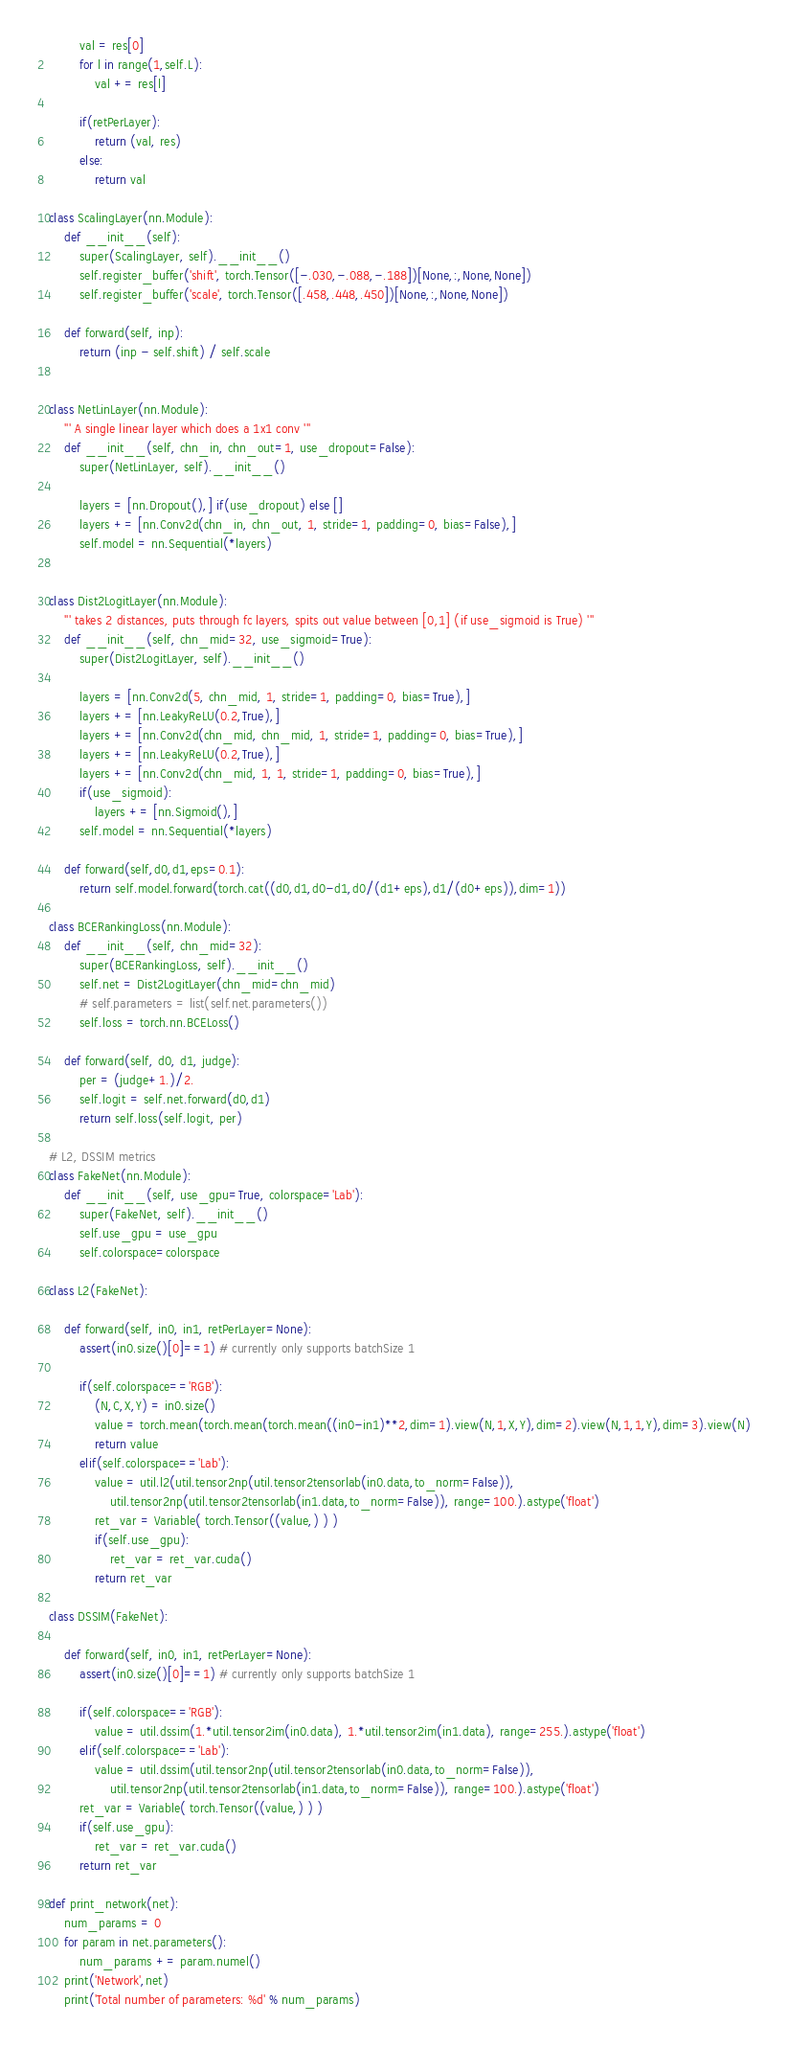<code> <loc_0><loc_0><loc_500><loc_500><_Python_>
        val = res[0]
        for l in range(1,self.L):
            val += res[l]
        
        if(retPerLayer):
            return (val, res)
        else:
            return val

class ScalingLayer(nn.Module):
    def __init__(self):
        super(ScalingLayer, self).__init__()
        self.register_buffer('shift', torch.Tensor([-.030,-.088,-.188])[None,:,None,None])
        self.register_buffer('scale', torch.Tensor([.458,.448,.450])[None,:,None,None])

    def forward(self, inp):
        return (inp - self.shift) / self.scale


class NetLinLayer(nn.Module):
    ''' A single linear layer which does a 1x1 conv '''
    def __init__(self, chn_in, chn_out=1, use_dropout=False):
        super(NetLinLayer, self).__init__()

        layers = [nn.Dropout(),] if(use_dropout) else []
        layers += [nn.Conv2d(chn_in, chn_out, 1, stride=1, padding=0, bias=False),]
        self.model = nn.Sequential(*layers)


class Dist2LogitLayer(nn.Module):
    ''' takes 2 distances, puts through fc layers, spits out value between [0,1] (if use_sigmoid is True) '''
    def __init__(self, chn_mid=32, use_sigmoid=True):
        super(Dist2LogitLayer, self).__init__()

        layers = [nn.Conv2d(5, chn_mid, 1, stride=1, padding=0, bias=True),]
        layers += [nn.LeakyReLU(0.2,True),]
        layers += [nn.Conv2d(chn_mid, chn_mid, 1, stride=1, padding=0, bias=True),]
        layers += [nn.LeakyReLU(0.2,True),]
        layers += [nn.Conv2d(chn_mid, 1, 1, stride=1, padding=0, bias=True),]
        if(use_sigmoid):
            layers += [nn.Sigmoid(),]
        self.model = nn.Sequential(*layers)

    def forward(self,d0,d1,eps=0.1):
        return self.model.forward(torch.cat((d0,d1,d0-d1,d0/(d1+eps),d1/(d0+eps)),dim=1))

class BCERankingLoss(nn.Module):
    def __init__(self, chn_mid=32):
        super(BCERankingLoss, self).__init__()
        self.net = Dist2LogitLayer(chn_mid=chn_mid)
        # self.parameters = list(self.net.parameters())
        self.loss = torch.nn.BCELoss()

    def forward(self, d0, d1, judge):
        per = (judge+1.)/2.
        self.logit = self.net.forward(d0,d1)
        return self.loss(self.logit, per)

# L2, DSSIM metrics
class FakeNet(nn.Module):
    def __init__(self, use_gpu=True, colorspace='Lab'):
        super(FakeNet, self).__init__()
        self.use_gpu = use_gpu
        self.colorspace=colorspace

class L2(FakeNet):

    def forward(self, in0, in1, retPerLayer=None):
        assert(in0.size()[0]==1) # currently only supports batchSize 1

        if(self.colorspace=='RGB'):
            (N,C,X,Y) = in0.size()
            value = torch.mean(torch.mean(torch.mean((in0-in1)**2,dim=1).view(N,1,X,Y),dim=2).view(N,1,1,Y),dim=3).view(N)
            return value
        elif(self.colorspace=='Lab'):
            value = util.l2(util.tensor2np(util.tensor2tensorlab(in0.data,to_norm=False)), 
                util.tensor2np(util.tensor2tensorlab(in1.data,to_norm=False)), range=100.).astype('float')
            ret_var = Variable( torch.Tensor((value,) ) )
            if(self.use_gpu):
                ret_var = ret_var.cuda()
            return ret_var

class DSSIM(FakeNet):

    def forward(self, in0, in1, retPerLayer=None):
        assert(in0.size()[0]==1) # currently only supports batchSize 1

        if(self.colorspace=='RGB'):
            value = util.dssim(1.*util.tensor2im(in0.data), 1.*util.tensor2im(in1.data), range=255.).astype('float')
        elif(self.colorspace=='Lab'):
            value = util.dssim(util.tensor2np(util.tensor2tensorlab(in0.data,to_norm=False)), 
                util.tensor2np(util.tensor2tensorlab(in1.data,to_norm=False)), range=100.).astype('float')
        ret_var = Variable( torch.Tensor((value,) ) )
        if(self.use_gpu):
            ret_var = ret_var.cuda()
        return ret_var

def print_network(net):
    num_params = 0
    for param in net.parameters():
        num_params += param.numel()
    print('Network',net)
    print('Total number of parameters: %d' % num_params)</code> 